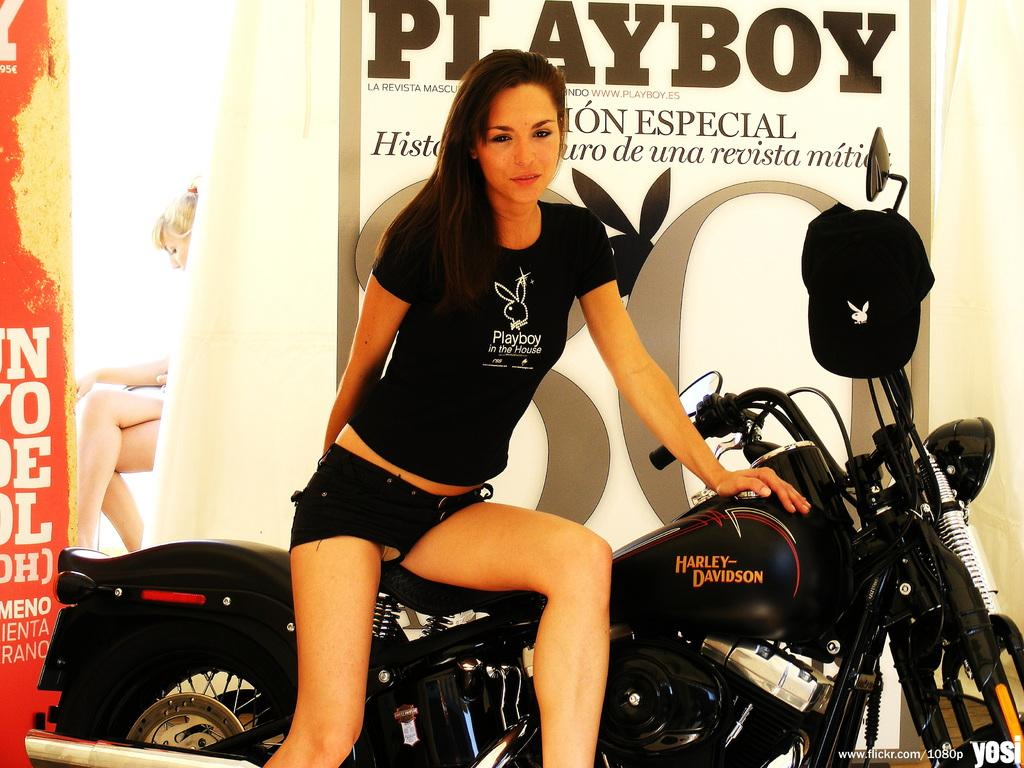What is the woman doing in the image? The woman is sitting on a vehicle. What can be seen in the background of the image? There is a banner in the background. Are there any other people visible in the image? Yes, there is a girl sitting in the left background. What type of juice is being compared in the image? There is no juice present in the image, nor is there any comparison being made. 